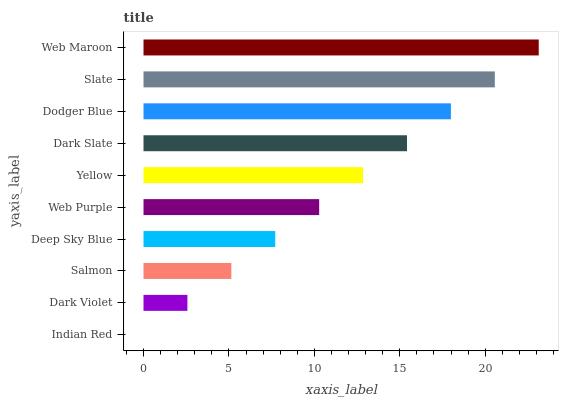Is Indian Red the minimum?
Answer yes or no. Yes. Is Web Maroon the maximum?
Answer yes or no. Yes. Is Dark Violet the minimum?
Answer yes or no. No. Is Dark Violet the maximum?
Answer yes or no. No. Is Dark Violet greater than Indian Red?
Answer yes or no. Yes. Is Indian Red less than Dark Violet?
Answer yes or no. Yes. Is Indian Red greater than Dark Violet?
Answer yes or no. No. Is Dark Violet less than Indian Red?
Answer yes or no. No. Is Yellow the high median?
Answer yes or no. Yes. Is Web Purple the low median?
Answer yes or no. Yes. Is Web Maroon the high median?
Answer yes or no. No. Is Indian Red the low median?
Answer yes or no. No. 